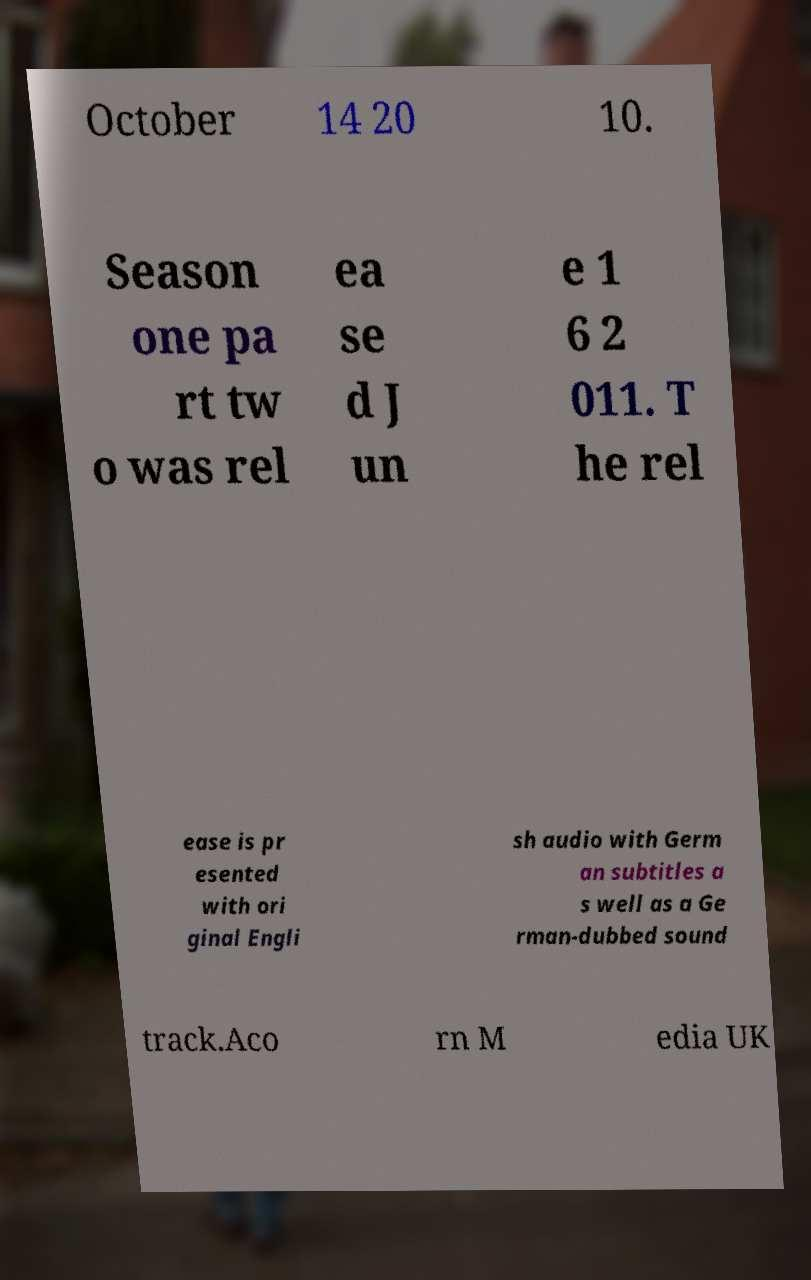What messages or text are displayed in this image? I need them in a readable, typed format. October 14 20 10. Season one pa rt tw o was rel ea se d J un e 1 6 2 011. T he rel ease is pr esented with ori ginal Engli sh audio with Germ an subtitles a s well as a Ge rman-dubbed sound track.Aco rn M edia UK 